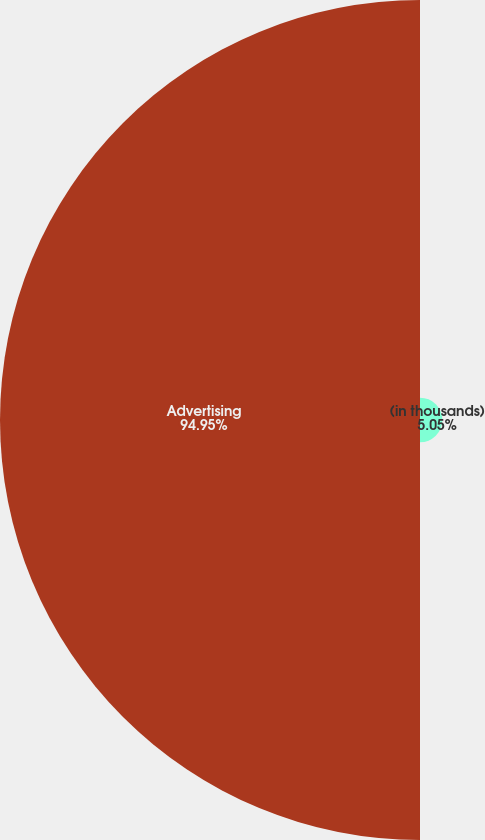<chart> <loc_0><loc_0><loc_500><loc_500><pie_chart><fcel>(in thousands)<fcel>Advertising<nl><fcel>5.05%<fcel>94.95%<nl></chart> 